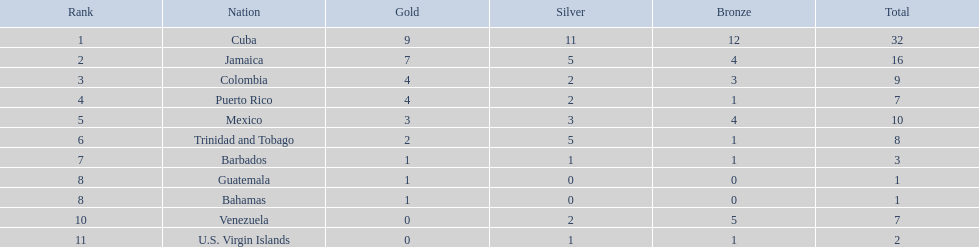Which three nations received the highest number of medals? Cuba, Jamaica, Colombia. Among these three, which ones are island countries? Cuba, Jamaica. Which one secured the most silver medals? Cuba. 